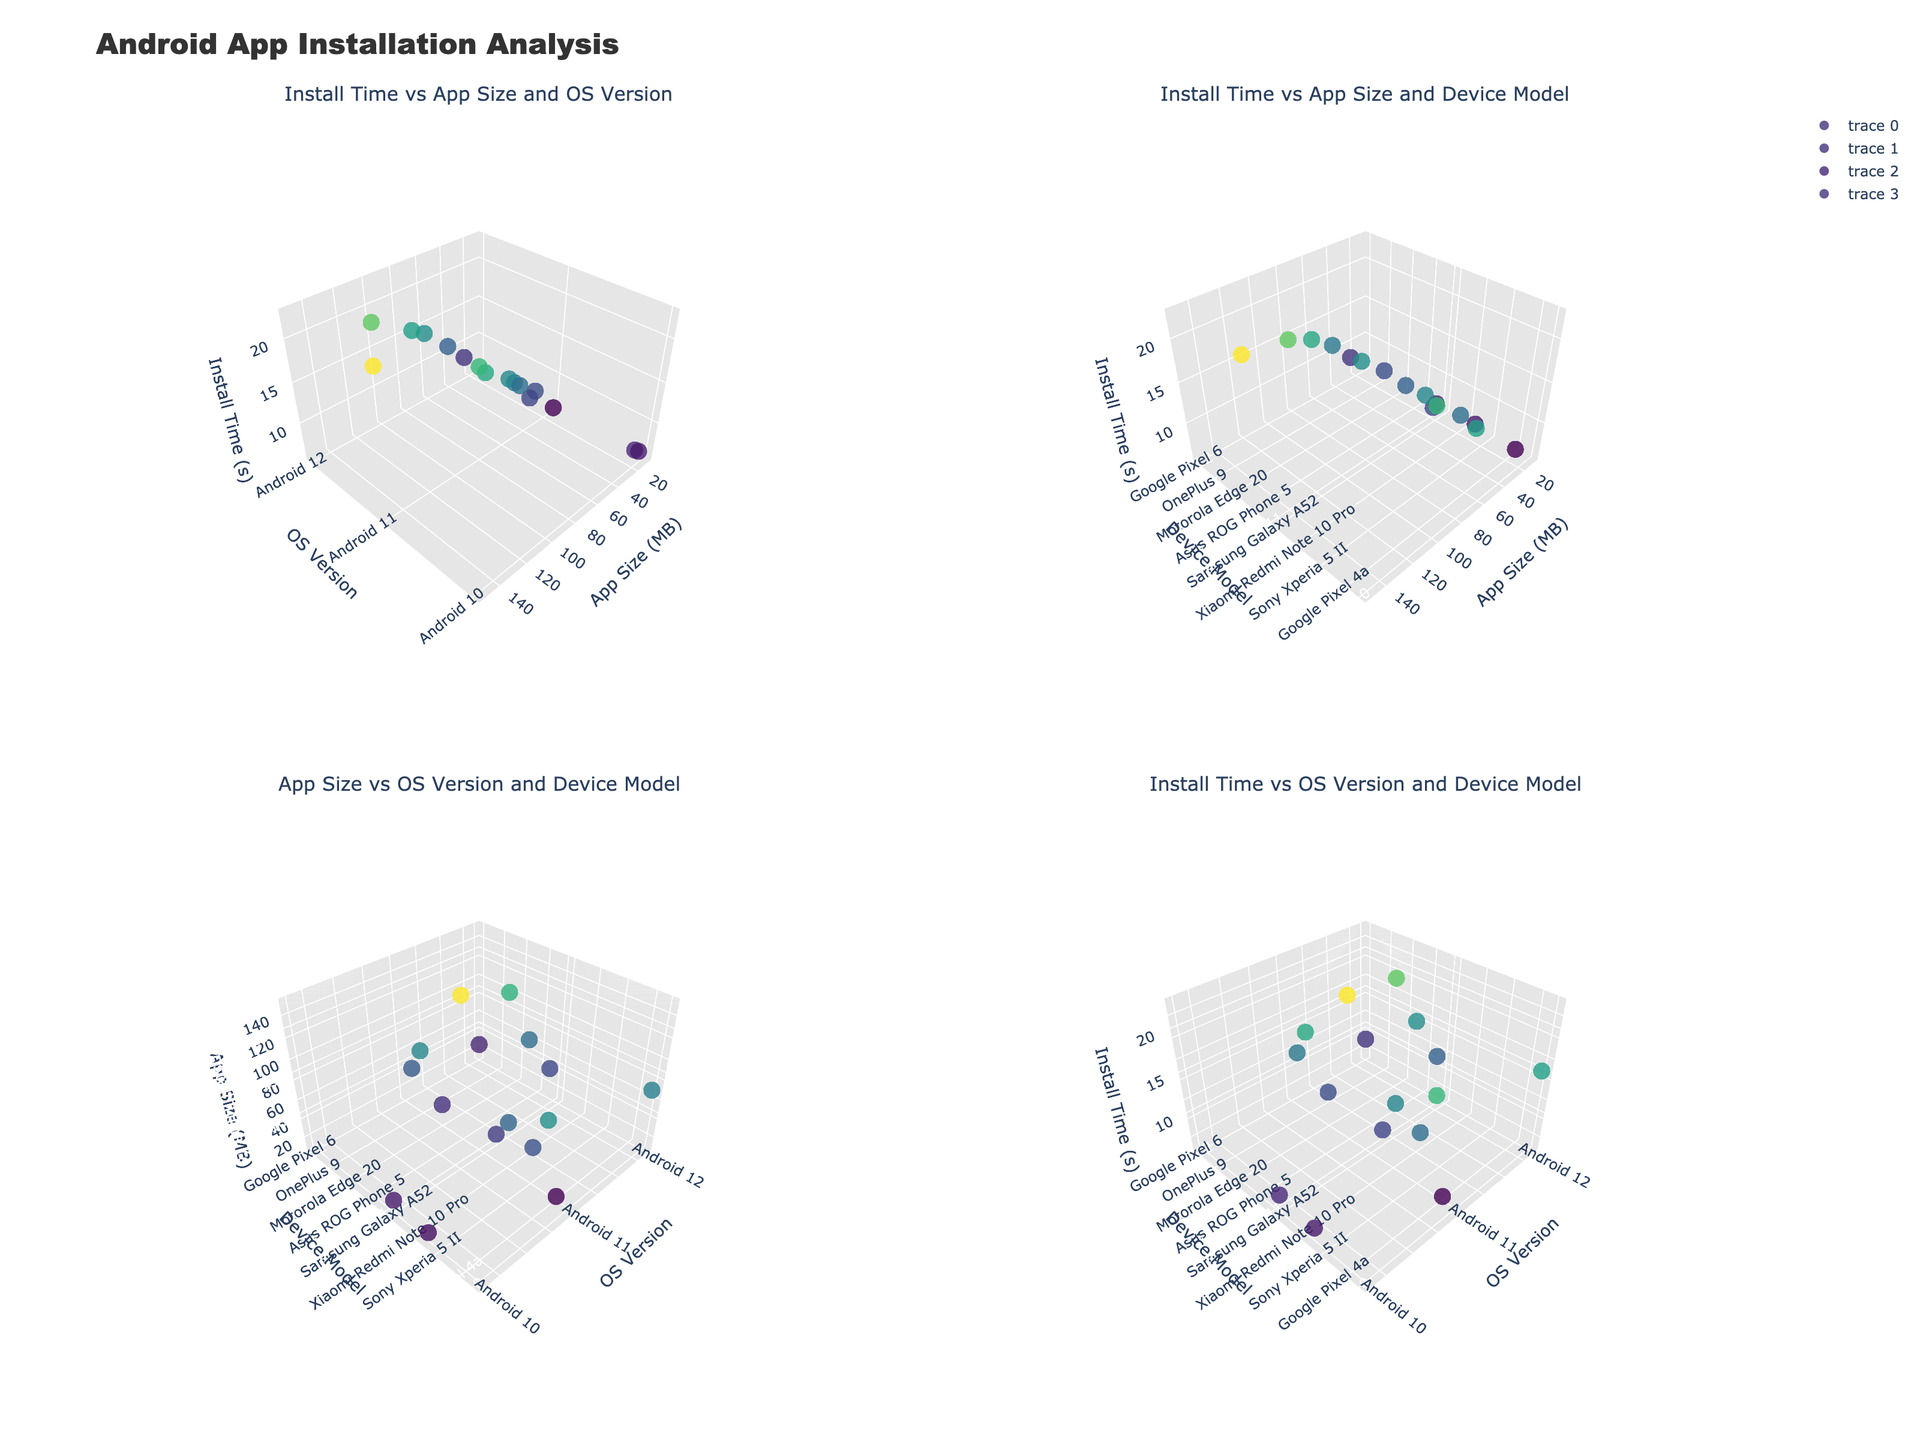which subplot shows the relationship between app size and os version? The third subplot (bottom left) titled "App Size vs OS Version and Device Model" shows the relationship between app size and OS version.
Answer: The third subplot how does the install time change with increasing app sizes according to the first subplot? In the first subplot (top left), the install time generally increases with increasing app sizes. Most larger apps take longer to install.
Answer: increases which device model has the shortest install time in the second subplot? By examining the second subplot (top right), the Google Pixel 4a has the shortest install time of 5.6 seconds.
Answer: Google Pixel 4a how does the use of different os versions impact install times in the fourth subplot? In the fourth subplot (bottom right), it appears that devices running Android 10 have shorter install times compared to those running Android 11 or 12, indicating newer OS versions may result in longer install times.
Answer: Android 10: shorter, Android 11 and 12: longer which apps have install times greater than 15 seconds across all subplots? Apps installed on devices such as the Asus ROG Phone 5, Google Pixel 6, OnePlus 9, Xiaomi Mi 11, Sony Xperia 1 III, and Asus Zenfone 8 have install times greater than 15 seconds, as seen in all subplots.
Answer: Asus ROG Phone 5, Google Pixel 6, OnePlus 9, Xiaomi Mi 11, Sony Xperia 1 III, Asus Zenfone 8 which os version has the largest range of install times in the first subplot? In the first subplot (top left), Android 11 has the largest range of install times, ranging from about 5.6 seconds to 22.6 seconds, compared to the other OS versions.
Answer: Android 11 which device model with Android 12 has the longest install time in the first subplot? In the first subplot (top left), the Xiaomi Mi 11 running Android 12 has the longest install time of 18.3 seconds.
Answer: Xiaomi Mi 11 